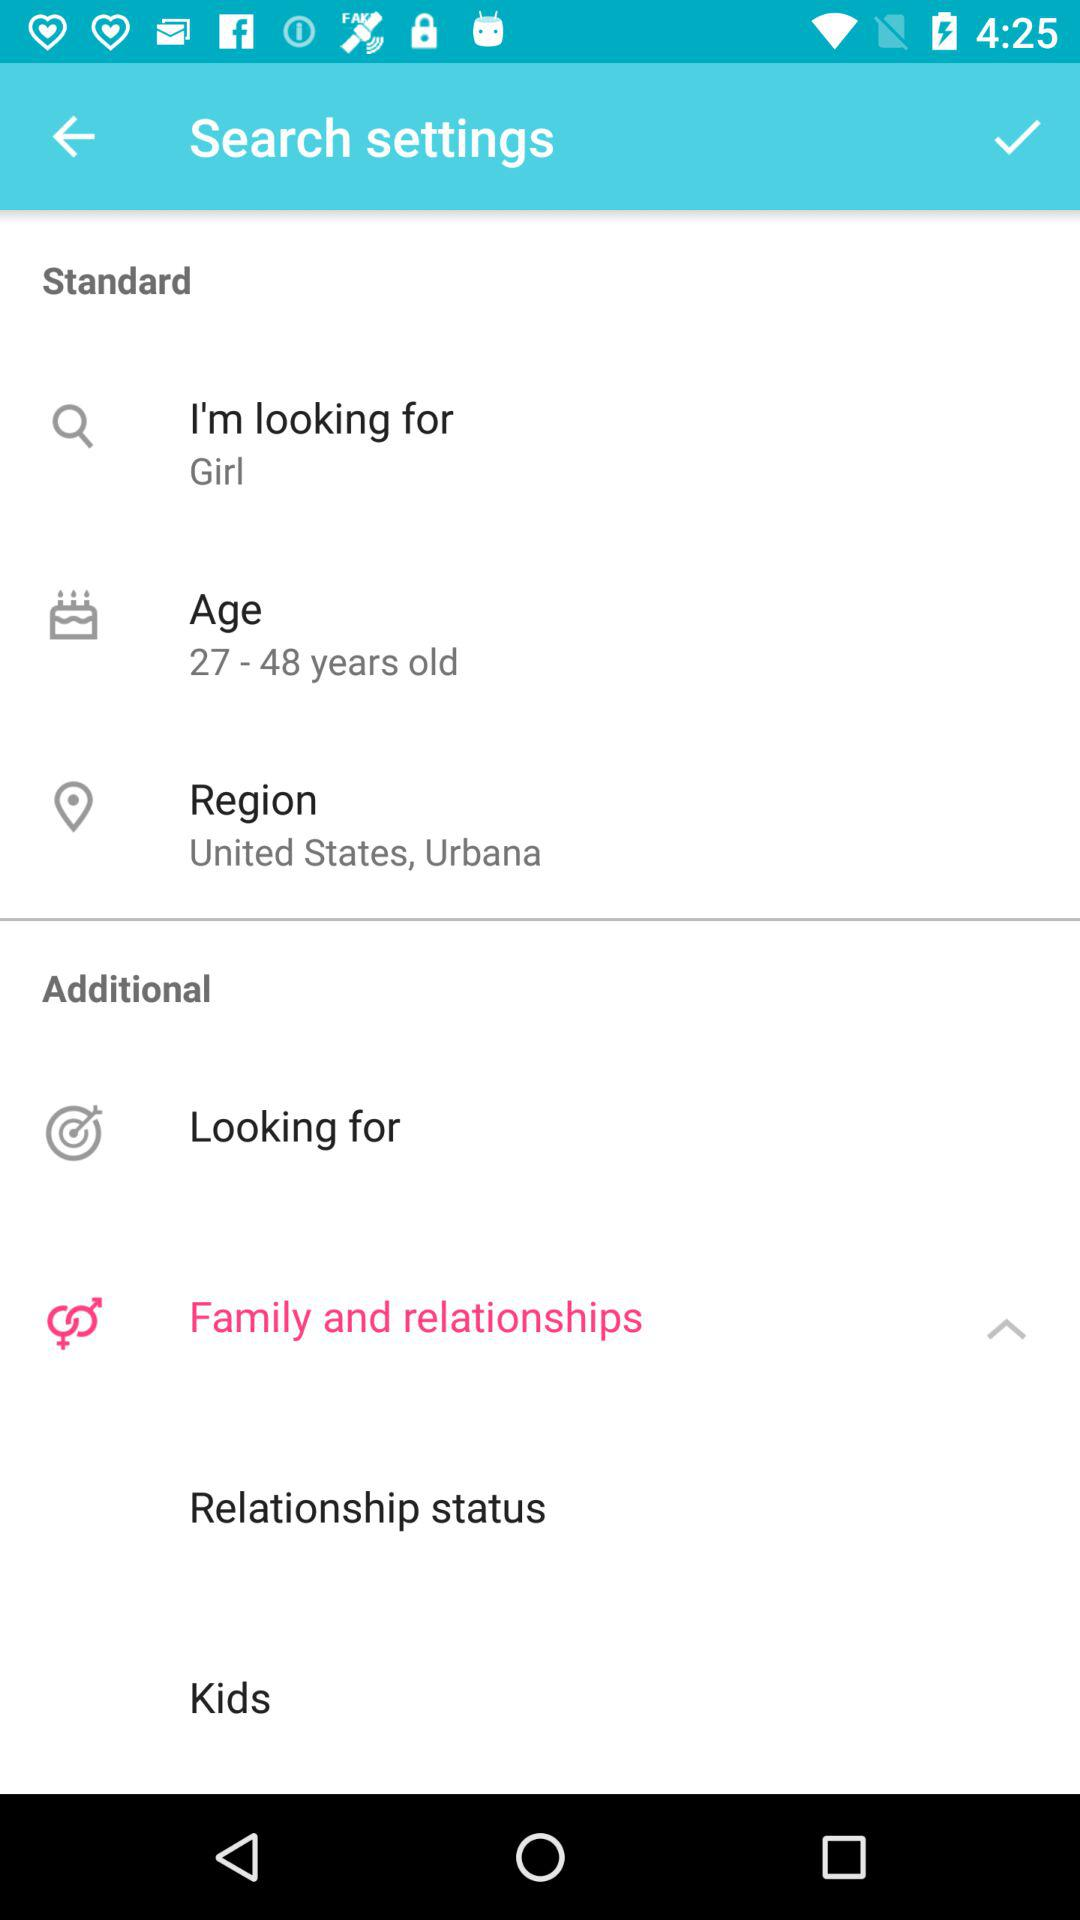What is the age? The age ranges from 27 to 48 years. 